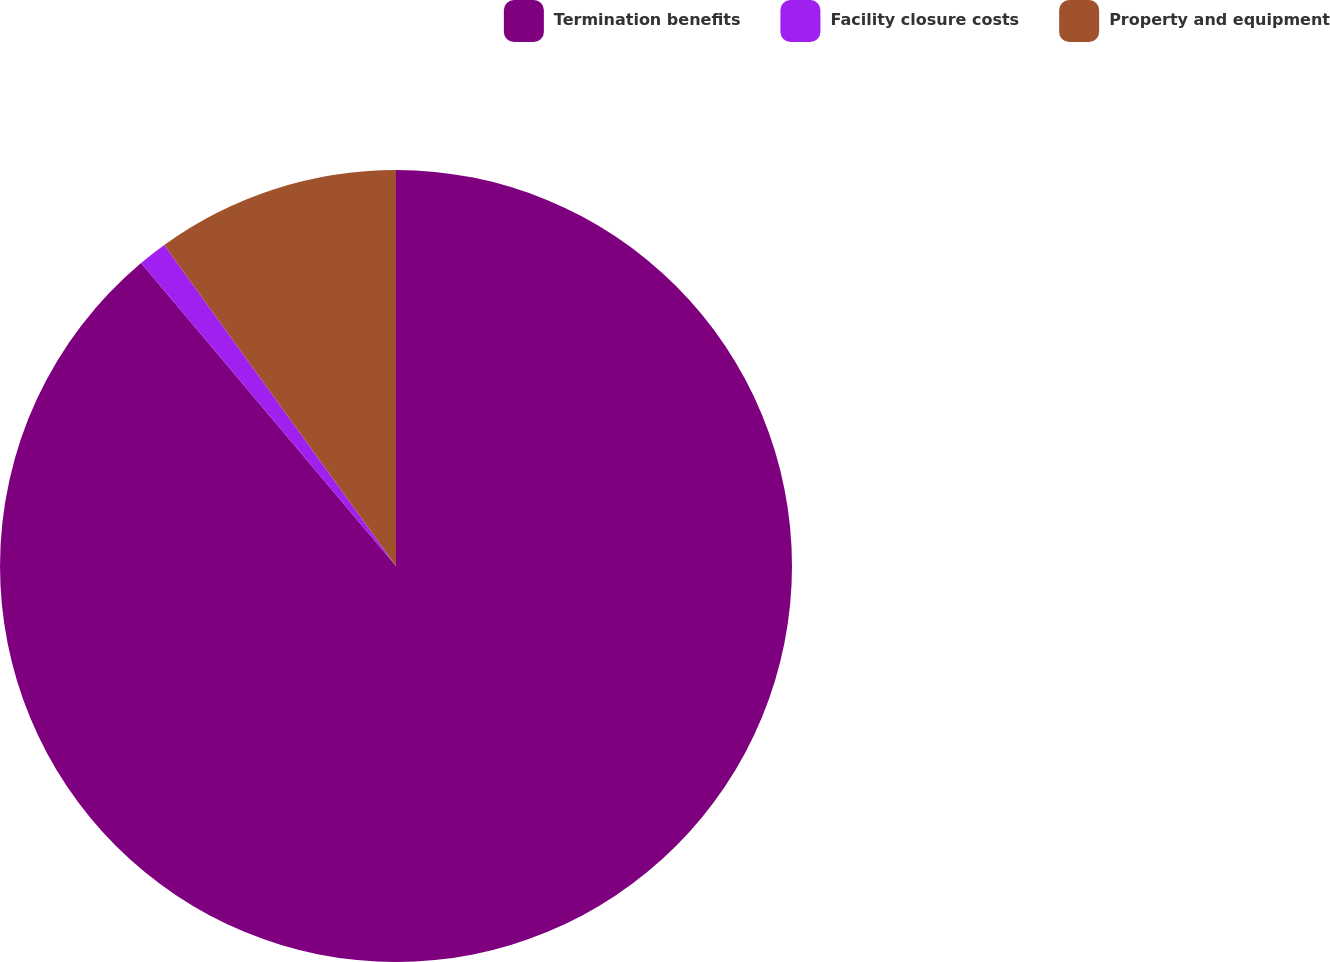<chart> <loc_0><loc_0><loc_500><loc_500><pie_chart><fcel>Termination benefits<fcel>Facility closure costs<fcel>Property and equipment<nl><fcel>88.86%<fcel>1.18%<fcel>9.95%<nl></chart> 